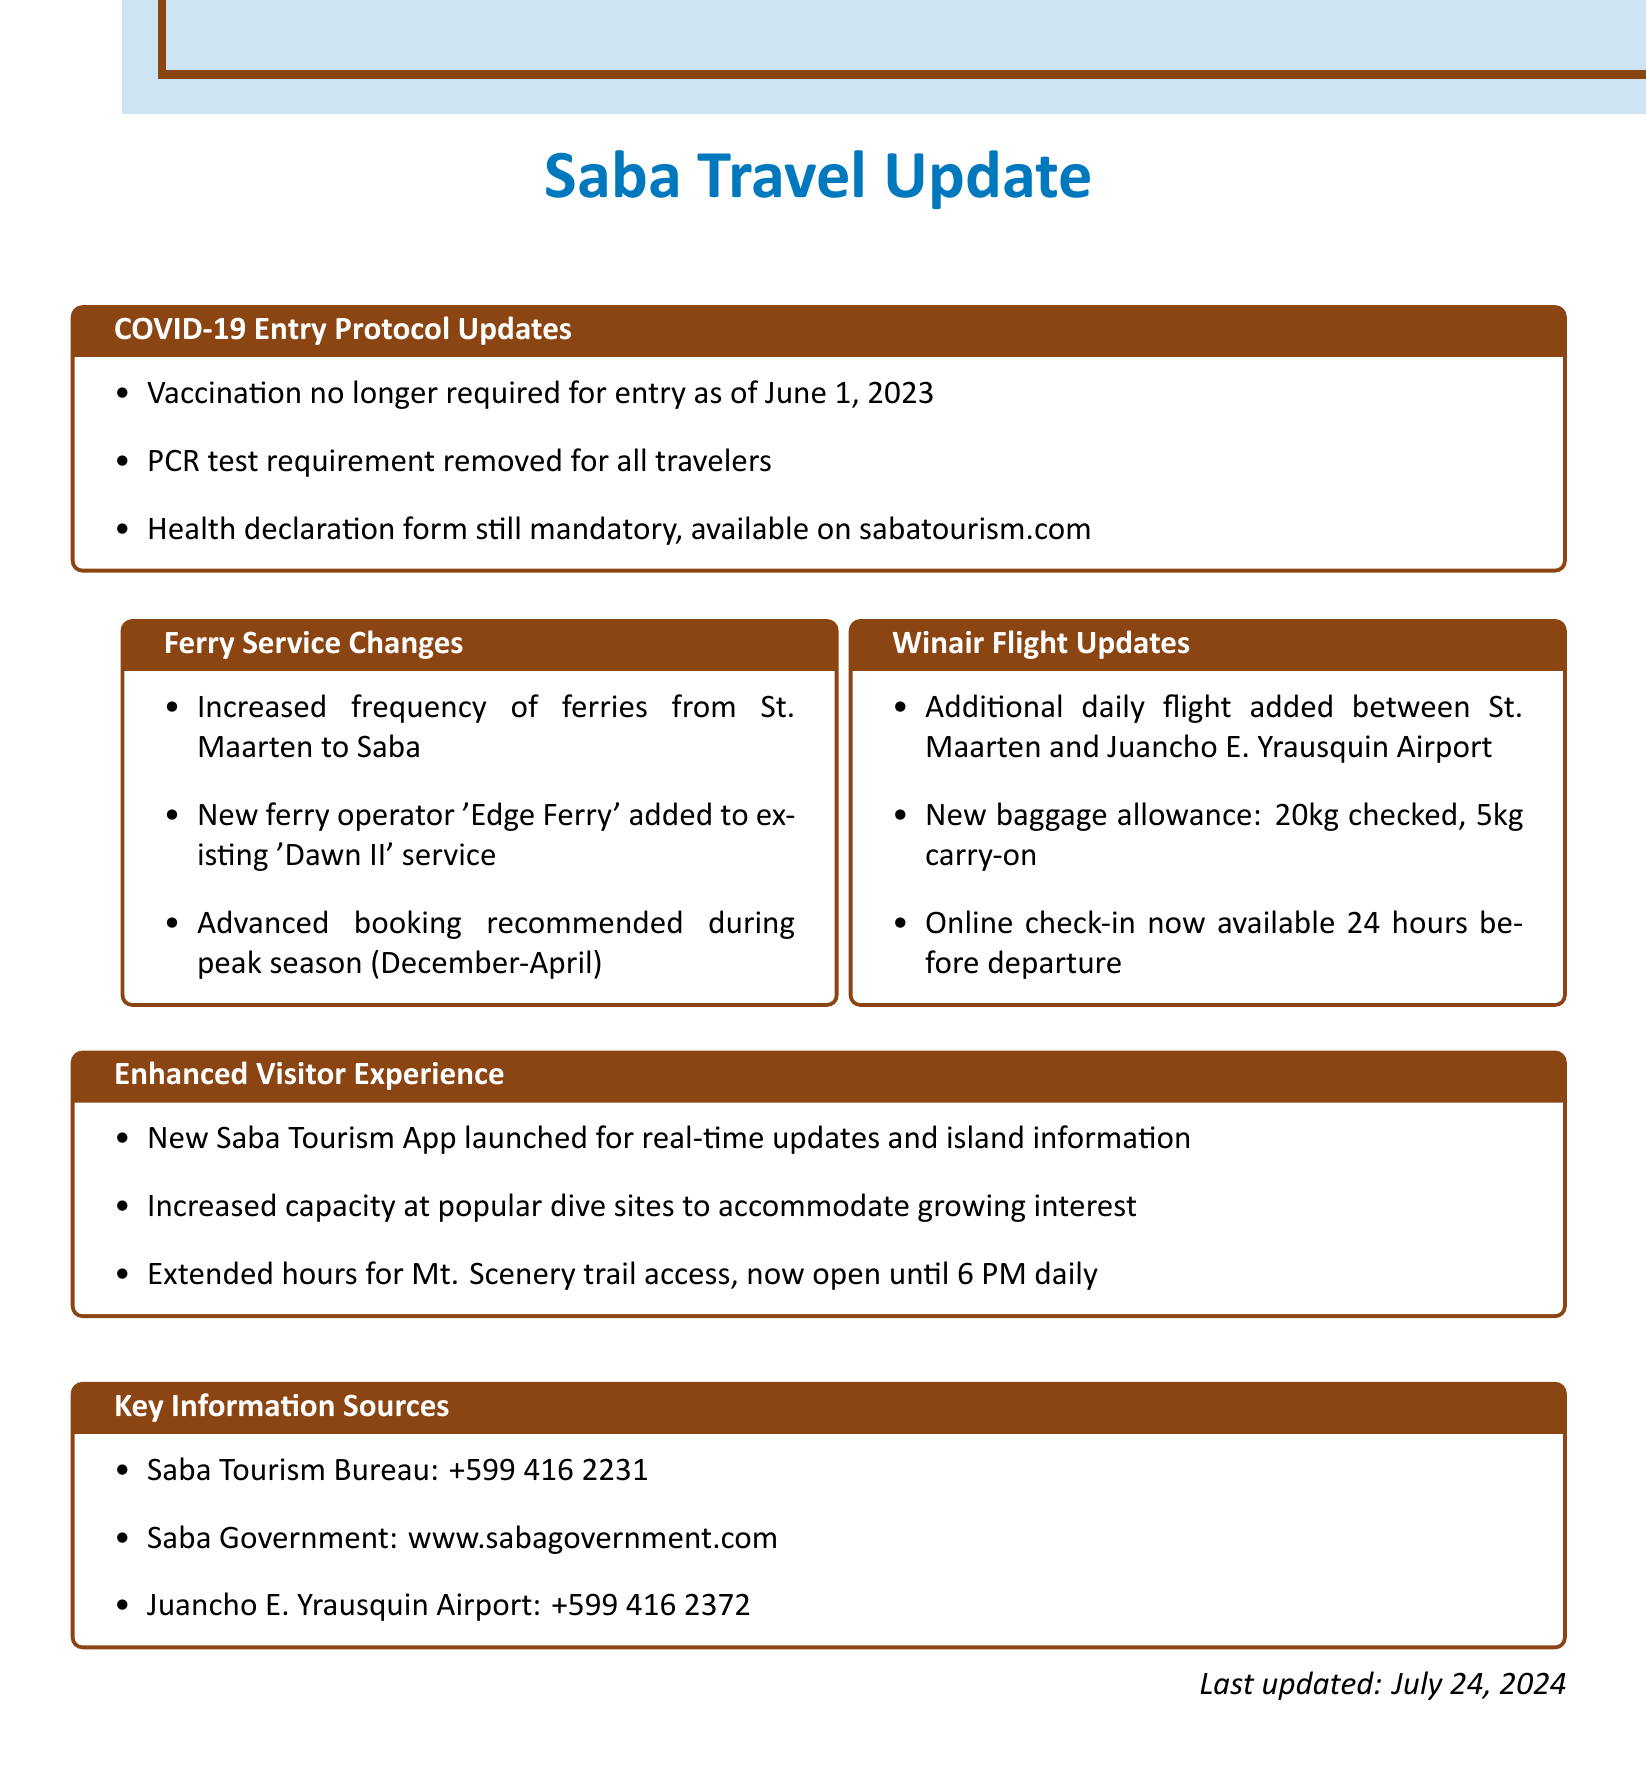What date did the vaccination requirement end? The document states that vaccination is no longer required for entry as of June 1, 2023.
Answer: June 1, 2023 What is the new baggage allowance on Winair flights? The document specifies the new baggage allowance is 20kg checked and 5kg carry-on.
Answer: 20kg checked, 5kg carry-on Which ferry operator was added to the Saba service? The document mentions the new ferry operator 'Edge Ferry' added to the existing 'Dawn II' service.
Answer: Edge Ferry What is still mandatory for entry into Saba? The document indicates that the health declaration form is still mandatory for travelers entering Saba.
Answer: Health declaration form What is the maximum time for access to Mt. Scenery trail? The document states that the trail is now open until 6 PM daily.
Answer: 6 PM How often should travelers book ferries during peak season? The document recommends advanced booking during peak season, which is December to April.
Answer: Advanced booking What is the contact number for the Saba Tourism Bureau? The document lists the contact number for the Saba Tourism Bureau as +599 416 2231.
Answer: +599 416 2231 What new app has been launched for visitors? The document mentions a new Saba Tourism App launched for real-time updates and island information.
Answer: Saba Tourism App 